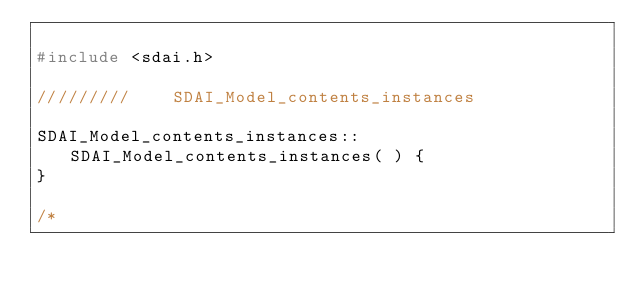Convert code to text. <code><loc_0><loc_0><loc_500><loc_500><_C++_>
#include <sdai.h>

/////////    SDAI_Model_contents_instances

SDAI_Model_contents_instances::SDAI_Model_contents_instances( ) {
}

/*</code> 